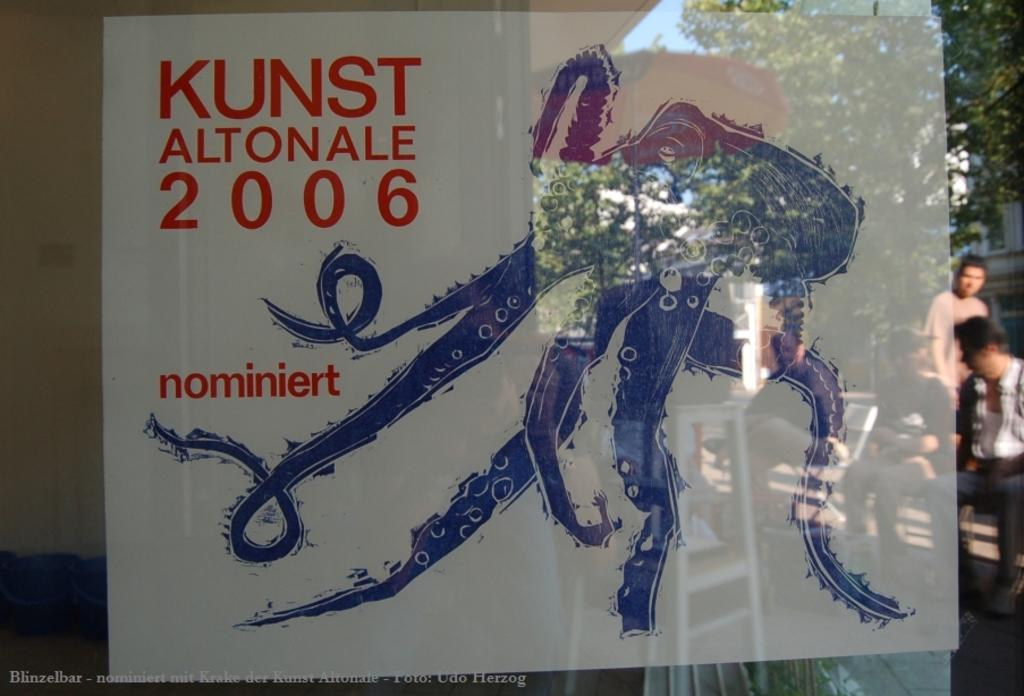<image>
Summarize the visual content of the image. A 2006 sign has a blue octopus drawn on it. 